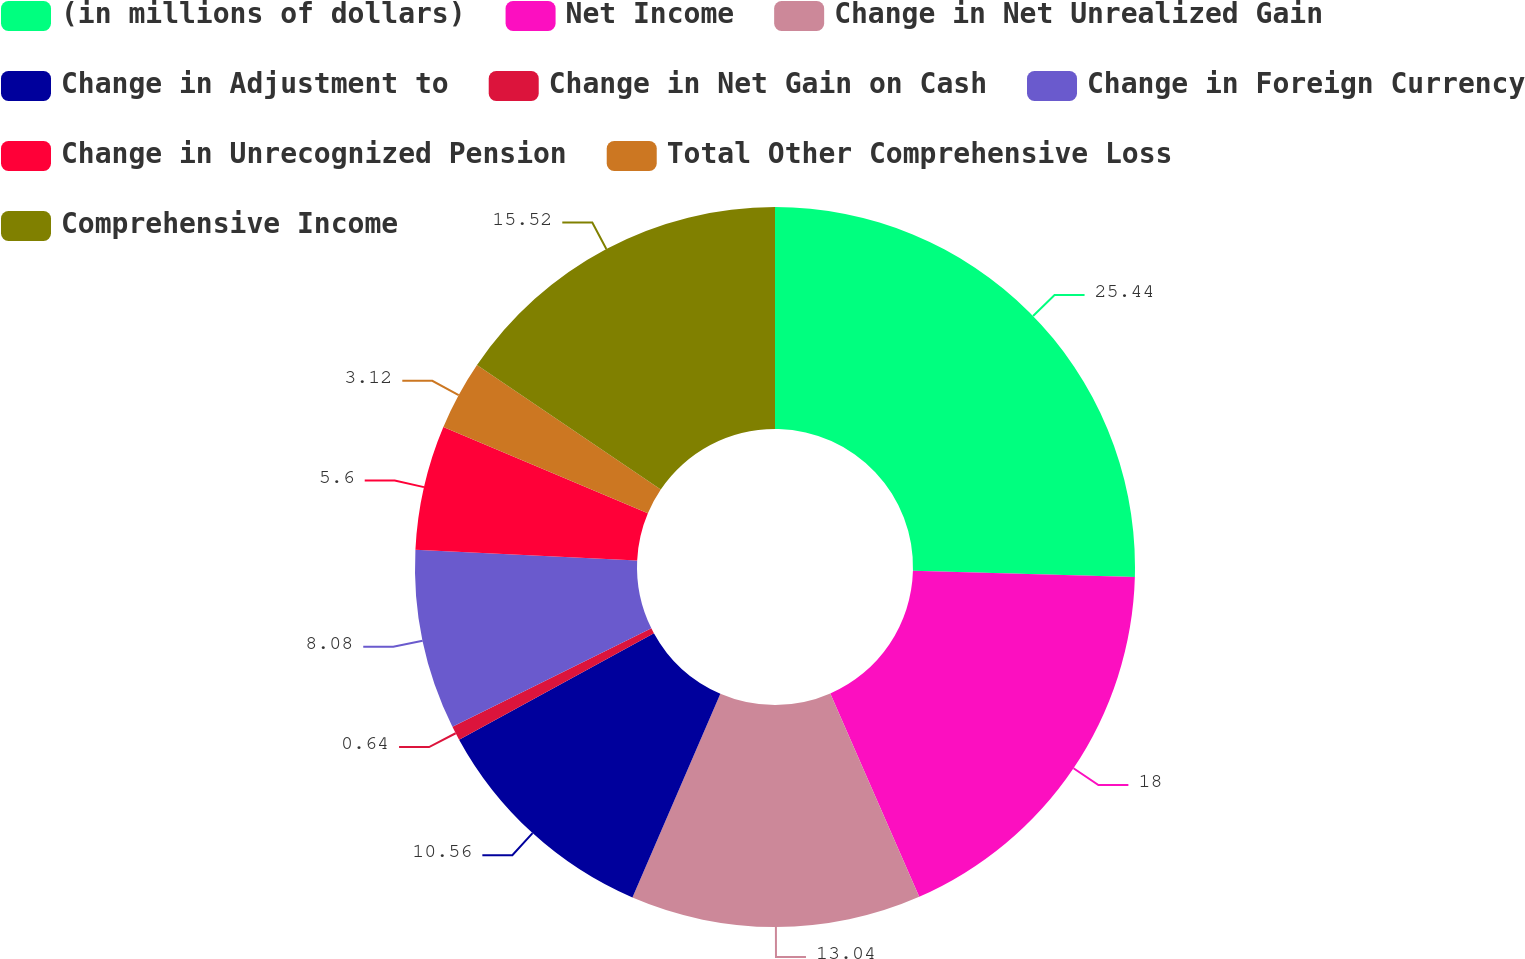<chart> <loc_0><loc_0><loc_500><loc_500><pie_chart><fcel>(in millions of dollars)<fcel>Net Income<fcel>Change in Net Unrealized Gain<fcel>Change in Adjustment to<fcel>Change in Net Gain on Cash<fcel>Change in Foreign Currency<fcel>Change in Unrecognized Pension<fcel>Total Other Comprehensive Loss<fcel>Comprehensive Income<nl><fcel>25.44%<fcel>18.0%<fcel>13.04%<fcel>10.56%<fcel>0.64%<fcel>8.08%<fcel>5.6%<fcel>3.12%<fcel>15.52%<nl></chart> 